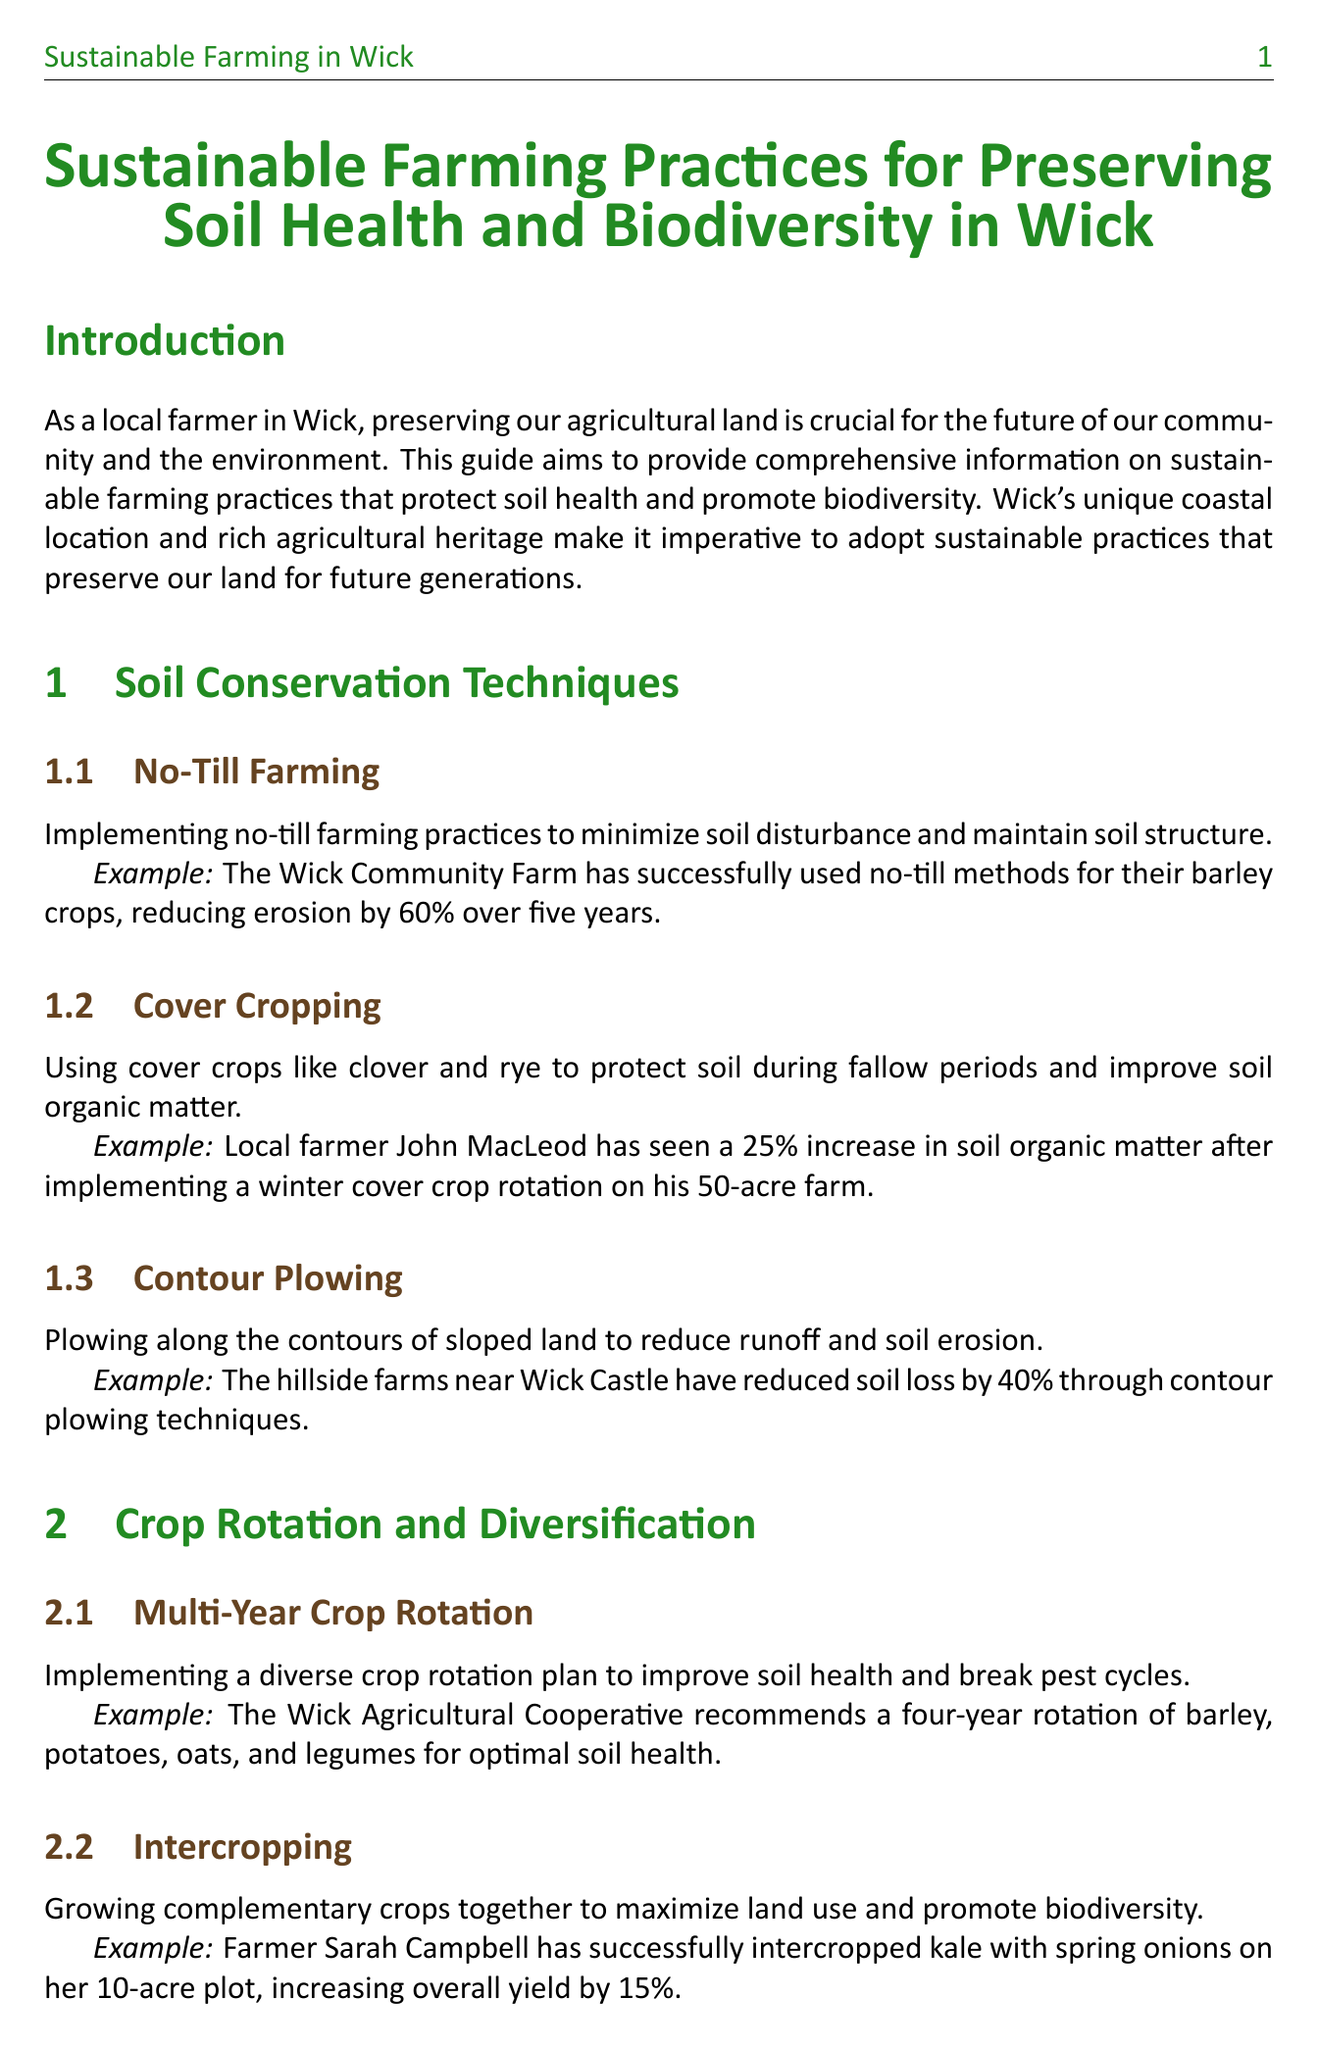What is the title of the guide? The title is the main heading displayed at the top of the document, which summarizes the content focus.
Answer: Sustainable Farming Practices for Preserving Soil Health and Biodiversity in Wick What is one example of a soil conservation technique? The document lists various techniques, highlighting specific examples under each technique.
Answer: No-Till Farming What percentage of water usage is reduced by the Wick Water Conservation Project? The document provides specific figures related to the effectiveness of implemented practices.
Answer: 30% Who is mentioned as having seen an increase in soil organic matter? The document cites local farmers with their achievements, particularly in soil health improvement.
Answer: John MacLeod What two crops are mentioned in the context of intercropping? The document illustrates intercropping by providing specific crop examples and their benefits.
Answer: Kale and Spring Onions How many kilometers of hedgerows have been restored by the Wick Biodiversity Initiative? The initiative's success in restoration is quantified in the document.
Answer: 5 km What is one benefit of wildflower margins mentioned in the document? The document explains the ecological advantages of dedicating land to wildflower margins.
Answer: Increase in pollinator activity Which organization offers discounted soil testing services? The document refers to specific organizations providing services to farmers for better agriculture practices.
Answer: Wick Soil Laboratory 